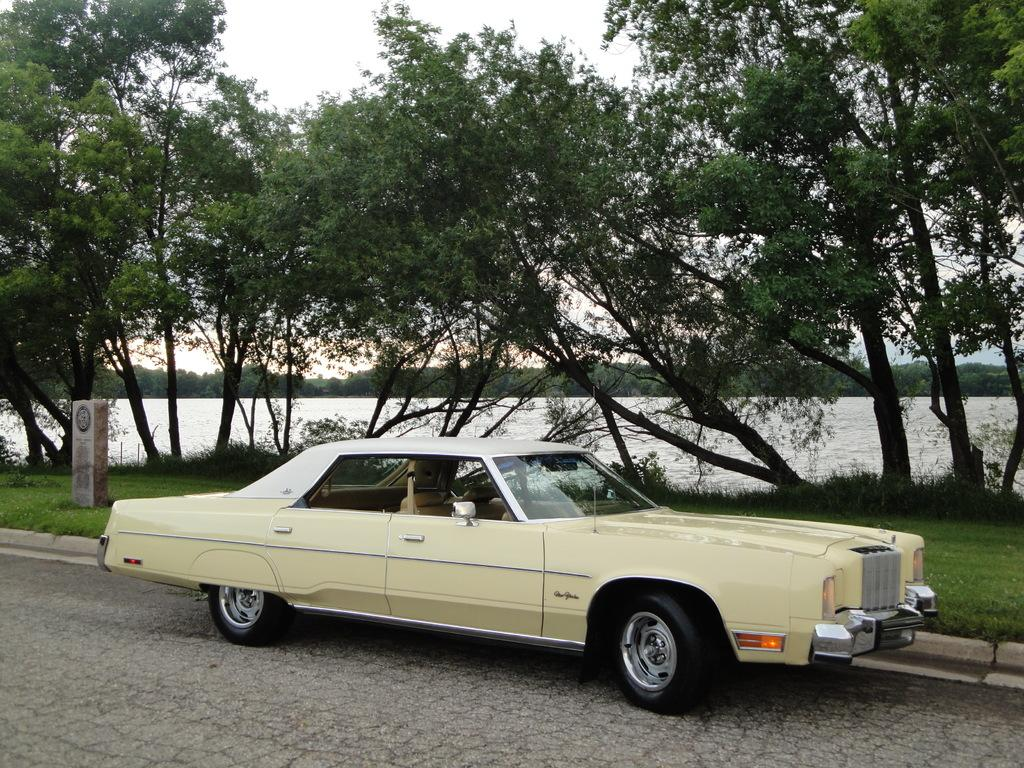What is the main subject of the image? There is a car in the image. Where is the car located? The car is on the road. What can be seen in the background of the image? There is grass, trees, a river, and the sky visible in the background of the image. How many rabbits are sitting on the car's roof in the image? There are no rabbits present in the image, so it is not possible to determine how many might be sitting on the car's roof. 